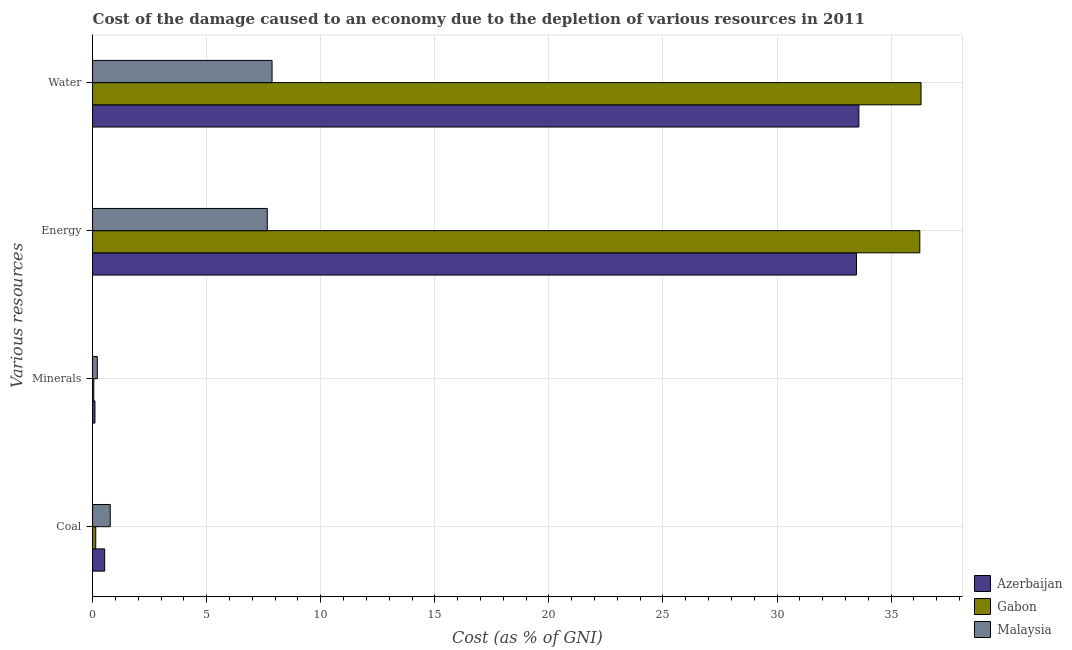How many groups of bars are there?
Your response must be concise. 4. How many bars are there on the 2nd tick from the bottom?
Your answer should be very brief. 3. What is the label of the 2nd group of bars from the top?
Your response must be concise. Energy. What is the cost of damage due to depletion of minerals in Azerbaijan?
Ensure brevity in your answer.  0.1. Across all countries, what is the maximum cost of damage due to depletion of minerals?
Give a very brief answer. 0.21. Across all countries, what is the minimum cost of damage due to depletion of coal?
Your answer should be compact. 0.14. In which country was the cost of damage due to depletion of water maximum?
Offer a very short reply. Gabon. In which country was the cost of damage due to depletion of coal minimum?
Your answer should be compact. Gabon. What is the total cost of damage due to depletion of water in the graph?
Keep it short and to the point. 77.76. What is the difference between the cost of damage due to depletion of coal in Azerbaijan and that in Gabon?
Offer a very short reply. 0.39. What is the difference between the cost of damage due to depletion of minerals in Gabon and the cost of damage due to depletion of energy in Malaysia?
Offer a terse response. -7.6. What is the average cost of damage due to depletion of coal per country?
Provide a succinct answer. 0.48. What is the difference between the cost of damage due to depletion of energy and cost of damage due to depletion of coal in Malaysia?
Your answer should be compact. 6.88. What is the ratio of the cost of damage due to depletion of minerals in Azerbaijan to that in Malaysia?
Ensure brevity in your answer.  0.5. Is the cost of damage due to depletion of minerals in Gabon less than that in Azerbaijan?
Give a very brief answer. Yes. What is the difference between the highest and the second highest cost of damage due to depletion of water?
Keep it short and to the point. 2.72. What is the difference between the highest and the lowest cost of damage due to depletion of water?
Ensure brevity in your answer.  28.44. In how many countries, is the cost of damage due to depletion of water greater than the average cost of damage due to depletion of water taken over all countries?
Your answer should be compact. 2. Is it the case that in every country, the sum of the cost of damage due to depletion of coal and cost of damage due to depletion of energy is greater than the sum of cost of damage due to depletion of water and cost of damage due to depletion of minerals?
Give a very brief answer. Yes. What does the 2nd bar from the top in Energy represents?
Provide a short and direct response. Gabon. What does the 1st bar from the bottom in Energy represents?
Offer a very short reply. Azerbaijan. Is it the case that in every country, the sum of the cost of damage due to depletion of coal and cost of damage due to depletion of minerals is greater than the cost of damage due to depletion of energy?
Your answer should be compact. No. Are all the bars in the graph horizontal?
Give a very brief answer. Yes. What is the difference between two consecutive major ticks on the X-axis?
Your answer should be compact. 5. Where does the legend appear in the graph?
Make the answer very short. Bottom right. How many legend labels are there?
Your response must be concise. 3. What is the title of the graph?
Keep it short and to the point. Cost of the damage caused to an economy due to the depletion of various resources in 2011 . Does "Aruba" appear as one of the legend labels in the graph?
Ensure brevity in your answer.  No. What is the label or title of the X-axis?
Ensure brevity in your answer.  Cost (as % of GNI). What is the label or title of the Y-axis?
Make the answer very short. Various resources. What is the Cost (as % of GNI) in Azerbaijan in Coal?
Give a very brief answer. 0.53. What is the Cost (as % of GNI) in Gabon in Coal?
Keep it short and to the point. 0.14. What is the Cost (as % of GNI) in Malaysia in Coal?
Provide a succinct answer. 0.78. What is the Cost (as % of GNI) of Azerbaijan in Minerals?
Offer a very short reply. 0.1. What is the Cost (as % of GNI) in Gabon in Minerals?
Your answer should be compact. 0.05. What is the Cost (as % of GNI) in Malaysia in Minerals?
Provide a short and direct response. 0.21. What is the Cost (as % of GNI) in Azerbaijan in Energy?
Your answer should be very brief. 33.48. What is the Cost (as % of GNI) in Gabon in Energy?
Make the answer very short. 36.26. What is the Cost (as % of GNI) of Malaysia in Energy?
Your answer should be very brief. 7.66. What is the Cost (as % of GNI) in Azerbaijan in Water?
Provide a succinct answer. 33.59. What is the Cost (as % of GNI) of Gabon in Water?
Your answer should be very brief. 36.31. What is the Cost (as % of GNI) of Malaysia in Water?
Give a very brief answer. 7.87. Across all Various resources, what is the maximum Cost (as % of GNI) in Azerbaijan?
Provide a short and direct response. 33.59. Across all Various resources, what is the maximum Cost (as % of GNI) of Gabon?
Your answer should be compact. 36.31. Across all Various resources, what is the maximum Cost (as % of GNI) in Malaysia?
Provide a short and direct response. 7.87. Across all Various resources, what is the minimum Cost (as % of GNI) in Azerbaijan?
Make the answer very short. 0.1. Across all Various resources, what is the minimum Cost (as % of GNI) in Gabon?
Your response must be concise. 0.05. Across all Various resources, what is the minimum Cost (as % of GNI) of Malaysia?
Your response must be concise. 0.21. What is the total Cost (as % of GNI) of Azerbaijan in the graph?
Give a very brief answer. 67.7. What is the total Cost (as % of GNI) of Gabon in the graph?
Provide a succinct answer. 72.76. What is the total Cost (as % of GNI) of Malaysia in the graph?
Make the answer very short. 16.51. What is the difference between the Cost (as % of GNI) of Azerbaijan in Coal and that in Minerals?
Give a very brief answer. 0.43. What is the difference between the Cost (as % of GNI) of Gabon in Coal and that in Minerals?
Make the answer very short. 0.08. What is the difference between the Cost (as % of GNI) in Malaysia in Coal and that in Minerals?
Your answer should be very brief. 0.57. What is the difference between the Cost (as % of GNI) in Azerbaijan in Coal and that in Energy?
Give a very brief answer. -32.95. What is the difference between the Cost (as % of GNI) of Gabon in Coal and that in Energy?
Offer a terse response. -36.12. What is the difference between the Cost (as % of GNI) in Malaysia in Coal and that in Energy?
Offer a terse response. -6.88. What is the difference between the Cost (as % of GNI) in Azerbaijan in Coal and that in Water?
Provide a succinct answer. -33.05. What is the difference between the Cost (as % of GNI) in Gabon in Coal and that in Water?
Give a very brief answer. -36.17. What is the difference between the Cost (as % of GNI) of Malaysia in Coal and that in Water?
Offer a terse response. -7.09. What is the difference between the Cost (as % of GNI) in Azerbaijan in Minerals and that in Energy?
Offer a terse response. -33.38. What is the difference between the Cost (as % of GNI) in Gabon in Minerals and that in Energy?
Offer a very short reply. -36.2. What is the difference between the Cost (as % of GNI) of Malaysia in Minerals and that in Energy?
Give a very brief answer. -7.45. What is the difference between the Cost (as % of GNI) in Azerbaijan in Minerals and that in Water?
Offer a very short reply. -33.48. What is the difference between the Cost (as % of GNI) of Gabon in Minerals and that in Water?
Keep it short and to the point. -36.26. What is the difference between the Cost (as % of GNI) in Malaysia in Minerals and that in Water?
Your answer should be very brief. -7.66. What is the difference between the Cost (as % of GNI) in Azerbaijan in Energy and that in Water?
Provide a short and direct response. -0.11. What is the difference between the Cost (as % of GNI) of Gabon in Energy and that in Water?
Your answer should be compact. -0.05. What is the difference between the Cost (as % of GNI) of Malaysia in Energy and that in Water?
Your response must be concise. -0.21. What is the difference between the Cost (as % of GNI) in Azerbaijan in Coal and the Cost (as % of GNI) in Gabon in Minerals?
Make the answer very short. 0.48. What is the difference between the Cost (as % of GNI) of Azerbaijan in Coal and the Cost (as % of GNI) of Malaysia in Minerals?
Make the answer very short. 0.32. What is the difference between the Cost (as % of GNI) of Gabon in Coal and the Cost (as % of GNI) of Malaysia in Minerals?
Provide a succinct answer. -0.07. What is the difference between the Cost (as % of GNI) of Azerbaijan in Coal and the Cost (as % of GNI) of Gabon in Energy?
Give a very brief answer. -35.73. What is the difference between the Cost (as % of GNI) in Azerbaijan in Coal and the Cost (as % of GNI) in Malaysia in Energy?
Your answer should be very brief. -7.13. What is the difference between the Cost (as % of GNI) of Gabon in Coal and the Cost (as % of GNI) of Malaysia in Energy?
Offer a terse response. -7.52. What is the difference between the Cost (as % of GNI) in Azerbaijan in Coal and the Cost (as % of GNI) in Gabon in Water?
Provide a succinct answer. -35.78. What is the difference between the Cost (as % of GNI) of Azerbaijan in Coal and the Cost (as % of GNI) of Malaysia in Water?
Give a very brief answer. -7.34. What is the difference between the Cost (as % of GNI) in Gabon in Coal and the Cost (as % of GNI) in Malaysia in Water?
Your answer should be compact. -7.73. What is the difference between the Cost (as % of GNI) in Azerbaijan in Minerals and the Cost (as % of GNI) in Gabon in Energy?
Keep it short and to the point. -36.15. What is the difference between the Cost (as % of GNI) of Azerbaijan in Minerals and the Cost (as % of GNI) of Malaysia in Energy?
Provide a succinct answer. -7.55. What is the difference between the Cost (as % of GNI) of Gabon in Minerals and the Cost (as % of GNI) of Malaysia in Energy?
Your answer should be compact. -7.6. What is the difference between the Cost (as % of GNI) in Azerbaijan in Minerals and the Cost (as % of GNI) in Gabon in Water?
Provide a short and direct response. -36.21. What is the difference between the Cost (as % of GNI) in Azerbaijan in Minerals and the Cost (as % of GNI) in Malaysia in Water?
Your response must be concise. -7.76. What is the difference between the Cost (as % of GNI) in Gabon in Minerals and the Cost (as % of GNI) in Malaysia in Water?
Make the answer very short. -7.81. What is the difference between the Cost (as % of GNI) in Azerbaijan in Energy and the Cost (as % of GNI) in Gabon in Water?
Ensure brevity in your answer.  -2.83. What is the difference between the Cost (as % of GNI) of Azerbaijan in Energy and the Cost (as % of GNI) of Malaysia in Water?
Provide a short and direct response. 25.61. What is the difference between the Cost (as % of GNI) of Gabon in Energy and the Cost (as % of GNI) of Malaysia in Water?
Provide a short and direct response. 28.39. What is the average Cost (as % of GNI) in Azerbaijan per Various resources?
Offer a terse response. 16.93. What is the average Cost (as % of GNI) of Gabon per Various resources?
Provide a succinct answer. 18.19. What is the average Cost (as % of GNI) of Malaysia per Various resources?
Keep it short and to the point. 4.13. What is the difference between the Cost (as % of GNI) in Azerbaijan and Cost (as % of GNI) in Gabon in Coal?
Your response must be concise. 0.39. What is the difference between the Cost (as % of GNI) of Azerbaijan and Cost (as % of GNI) of Malaysia in Coal?
Provide a short and direct response. -0.24. What is the difference between the Cost (as % of GNI) in Gabon and Cost (as % of GNI) in Malaysia in Coal?
Provide a succinct answer. -0.64. What is the difference between the Cost (as % of GNI) of Azerbaijan and Cost (as % of GNI) of Gabon in Minerals?
Provide a succinct answer. 0.05. What is the difference between the Cost (as % of GNI) in Azerbaijan and Cost (as % of GNI) in Malaysia in Minerals?
Offer a very short reply. -0.1. What is the difference between the Cost (as % of GNI) of Gabon and Cost (as % of GNI) of Malaysia in Minerals?
Provide a succinct answer. -0.15. What is the difference between the Cost (as % of GNI) of Azerbaijan and Cost (as % of GNI) of Gabon in Energy?
Give a very brief answer. -2.78. What is the difference between the Cost (as % of GNI) of Azerbaijan and Cost (as % of GNI) of Malaysia in Energy?
Offer a terse response. 25.82. What is the difference between the Cost (as % of GNI) in Gabon and Cost (as % of GNI) in Malaysia in Energy?
Provide a short and direct response. 28.6. What is the difference between the Cost (as % of GNI) of Azerbaijan and Cost (as % of GNI) of Gabon in Water?
Keep it short and to the point. -2.72. What is the difference between the Cost (as % of GNI) in Azerbaijan and Cost (as % of GNI) in Malaysia in Water?
Provide a short and direct response. 25.72. What is the difference between the Cost (as % of GNI) in Gabon and Cost (as % of GNI) in Malaysia in Water?
Make the answer very short. 28.44. What is the ratio of the Cost (as % of GNI) in Azerbaijan in Coal to that in Minerals?
Make the answer very short. 5.07. What is the ratio of the Cost (as % of GNI) in Gabon in Coal to that in Minerals?
Offer a terse response. 2.57. What is the ratio of the Cost (as % of GNI) of Malaysia in Coal to that in Minerals?
Provide a succinct answer. 3.71. What is the ratio of the Cost (as % of GNI) of Azerbaijan in Coal to that in Energy?
Ensure brevity in your answer.  0.02. What is the ratio of the Cost (as % of GNI) of Gabon in Coal to that in Energy?
Offer a terse response. 0. What is the ratio of the Cost (as % of GNI) in Malaysia in Coal to that in Energy?
Your response must be concise. 0.1. What is the ratio of the Cost (as % of GNI) of Azerbaijan in Coal to that in Water?
Provide a succinct answer. 0.02. What is the ratio of the Cost (as % of GNI) in Gabon in Coal to that in Water?
Provide a short and direct response. 0. What is the ratio of the Cost (as % of GNI) in Malaysia in Coal to that in Water?
Provide a short and direct response. 0.1. What is the ratio of the Cost (as % of GNI) in Azerbaijan in Minerals to that in Energy?
Make the answer very short. 0. What is the ratio of the Cost (as % of GNI) of Gabon in Minerals to that in Energy?
Ensure brevity in your answer.  0. What is the ratio of the Cost (as % of GNI) of Malaysia in Minerals to that in Energy?
Give a very brief answer. 0.03. What is the ratio of the Cost (as % of GNI) of Azerbaijan in Minerals to that in Water?
Provide a succinct answer. 0. What is the ratio of the Cost (as % of GNI) in Gabon in Minerals to that in Water?
Offer a very short reply. 0. What is the ratio of the Cost (as % of GNI) of Malaysia in Minerals to that in Water?
Keep it short and to the point. 0.03. What is the ratio of the Cost (as % of GNI) of Azerbaijan in Energy to that in Water?
Offer a very short reply. 1. What is the ratio of the Cost (as % of GNI) in Gabon in Energy to that in Water?
Your response must be concise. 1. What is the ratio of the Cost (as % of GNI) of Malaysia in Energy to that in Water?
Your answer should be compact. 0.97. What is the difference between the highest and the second highest Cost (as % of GNI) of Azerbaijan?
Give a very brief answer. 0.11. What is the difference between the highest and the second highest Cost (as % of GNI) in Gabon?
Provide a short and direct response. 0.05. What is the difference between the highest and the second highest Cost (as % of GNI) of Malaysia?
Your answer should be compact. 0.21. What is the difference between the highest and the lowest Cost (as % of GNI) of Azerbaijan?
Make the answer very short. 33.48. What is the difference between the highest and the lowest Cost (as % of GNI) in Gabon?
Make the answer very short. 36.26. What is the difference between the highest and the lowest Cost (as % of GNI) of Malaysia?
Keep it short and to the point. 7.66. 